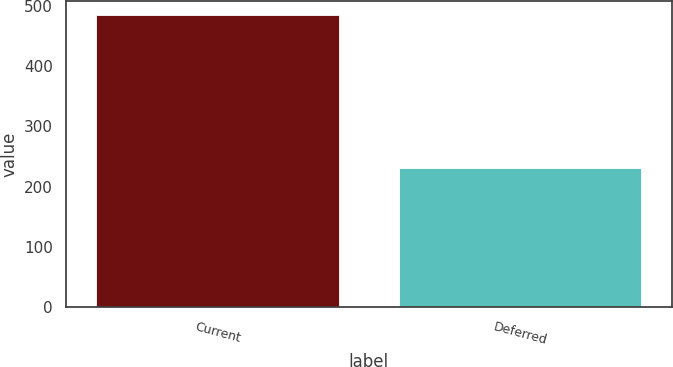Convert chart to OTSL. <chart><loc_0><loc_0><loc_500><loc_500><bar_chart><fcel>Current<fcel>Deferred<nl><fcel>484<fcel>231<nl></chart> 